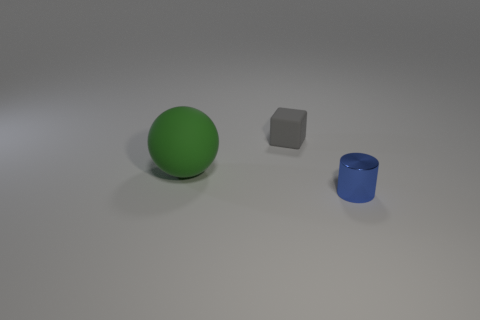There is a tiny blue metal cylinder; how many small blocks are behind it? Directly behind the tiny blue metal cylinder, there is one small gray block. 